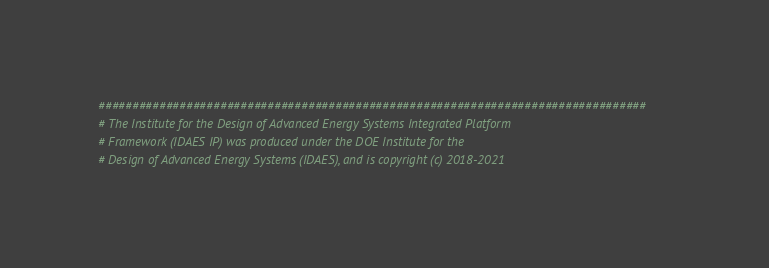<code> <loc_0><loc_0><loc_500><loc_500><_Python_>#################################################################################
# The Institute for the Design of Advanced Energy Systems Integrated Platform
# Framework (IDAES IP) was produced under the DOE Institute for the
# Design of Advanced Energy Systems (IDAES), and is copyright (c) 2018-2021</code> 